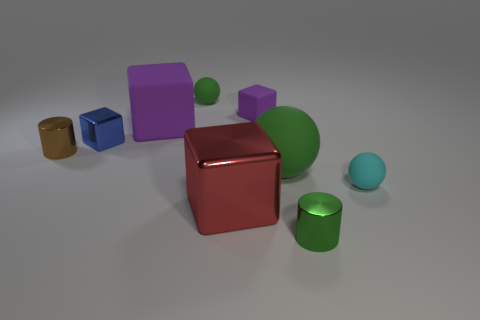Does the arrangement of shapes in the image suggest any particular theme? While the arrangement seems random at first glance, there might be a theme of balance and form at play here. Each shape is distinct and placed in such a way that they are in harmony with one another, possibly representing the idea that different elements can coexist peacefully in a shared space. 